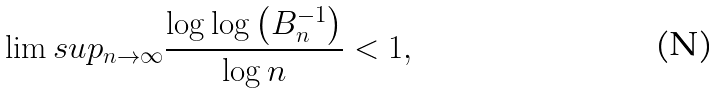<formula> <loc_0><loc_0><loc_500><loc_500>\lim s u p _ { n \to \infty } \frac { \log \log \left ( B _ { n } ^ { - 1 } \right ) } { \log n } < 1 ,</formula> 